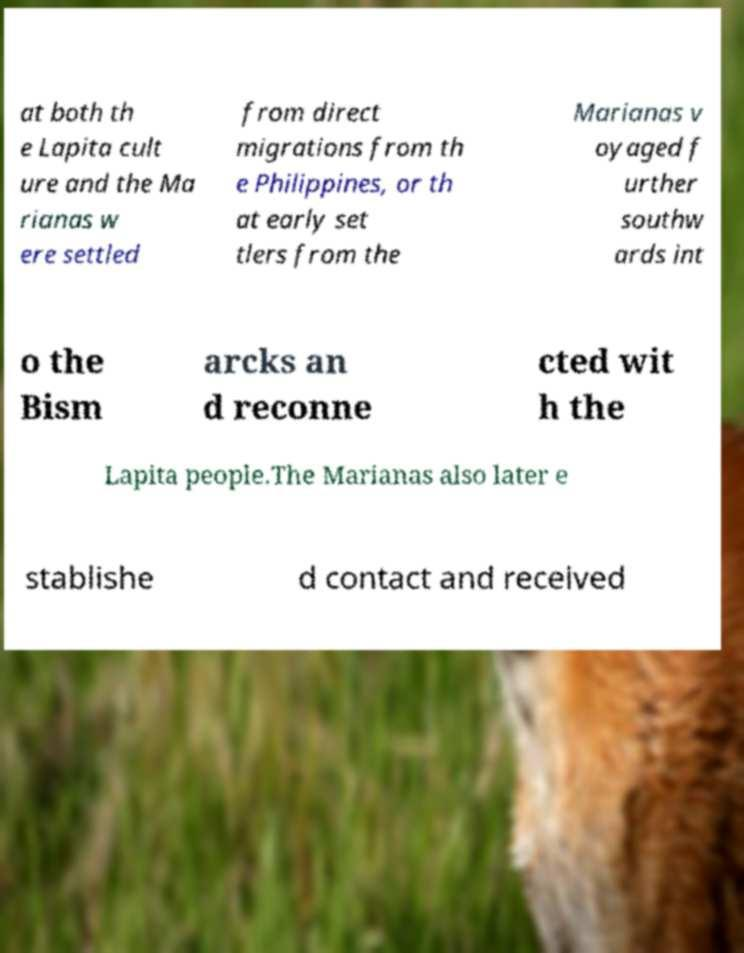For documentation purposes, I need the text within this image transcribed. Could you provide that? at both th e Lapita cult ure and the Ma rianas w ere settled from direct migrations from th e Philippines, or th at early set tlers from the Marianas v oyaged f urther southw ards int o the Bism arcks an d reconne cted wit h the Lapita people.The Marianas also later e stablishe d contact and received 